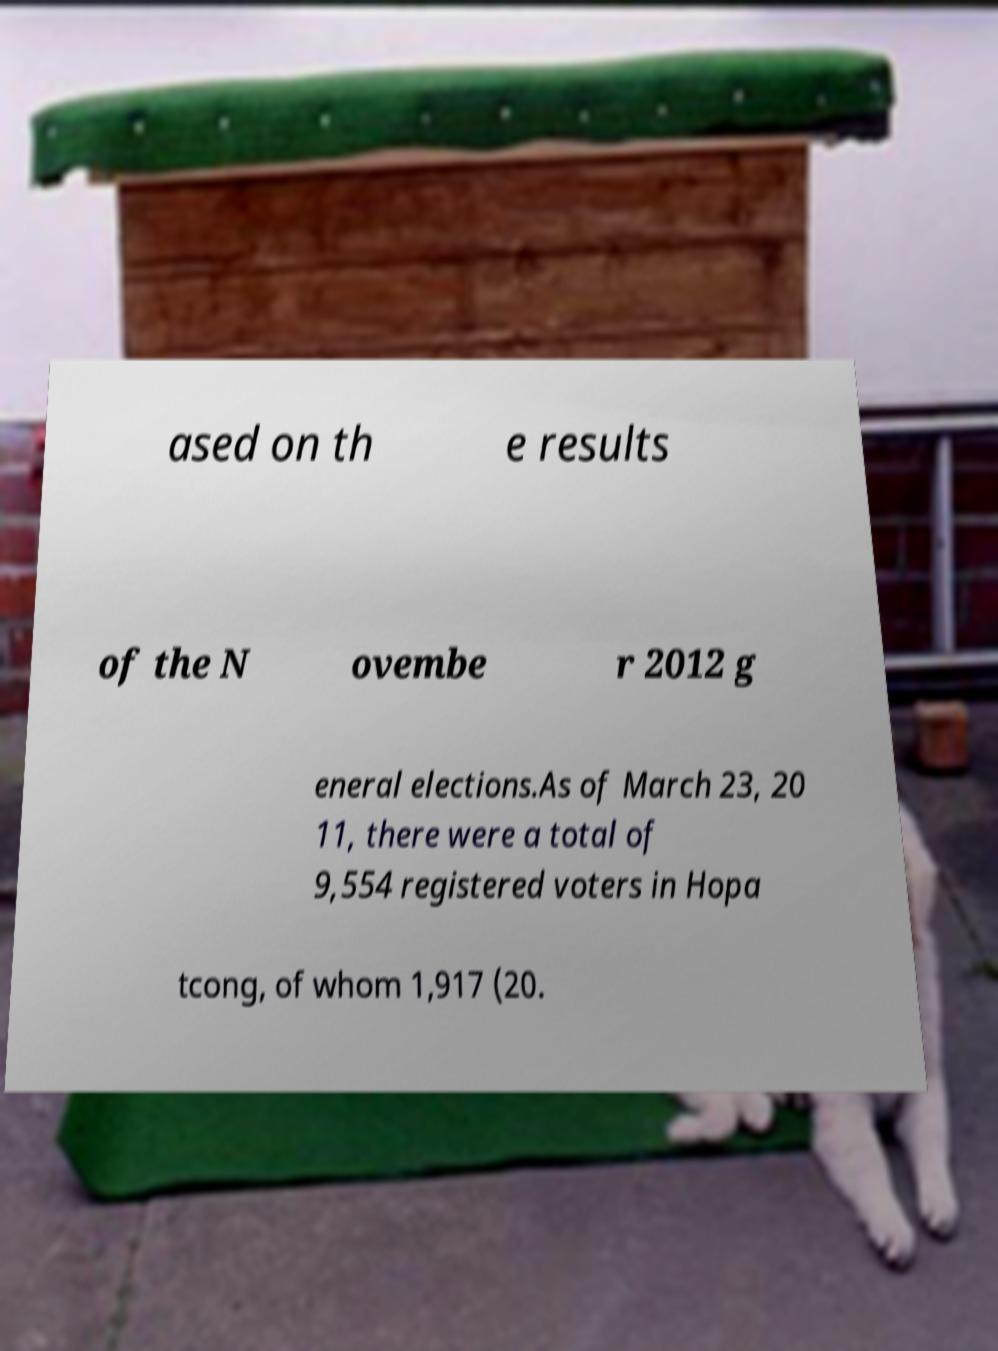Please identify and transcribe the text found in this image. ased on th e results of the N ovembe r 2012 g eneral elections.As of March 23, 20 11, there were a total of 9,554 registered voters in Hopa tcong, of whom 1,917 (20. 